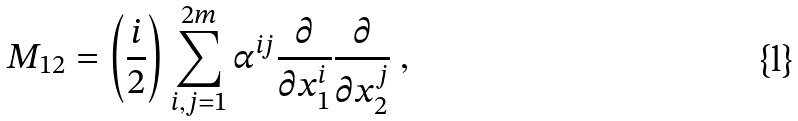<formula> <loc_0><loc_0><loc_500><loc_500>M _ { 1 2 } = \left ( \frac { i } { 2 } \right ) \sum _ { i , j = 1 } ^ { 2 m } \alpha ^ { i j } \frac { \partial } { \partial x _ { 1 } ^ { i } } \frac { \partial } { \partial x _ { 2 } ^ { j } } \ ,</formula> 